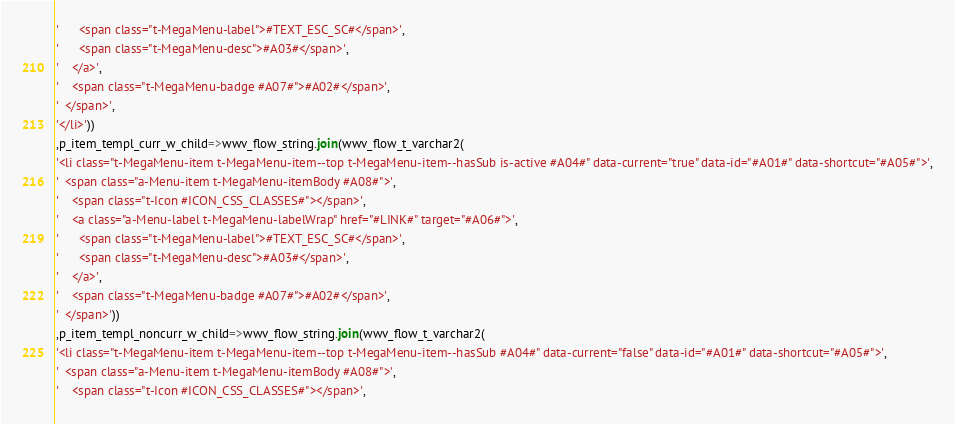<code> <loc_0><loc_0><loc_500><loc_500><_SQL_>'      <span class="t-MegaMenu-label">#TEXT_ESC_SC#</span>',
'      <span class="t-MegaMenu-desc">#A03#</span>',
'    </a>',
'    <span class="t-MegaMenu-badge #A07#">#A02#</span>',
'  </span>',
'</li>'))
,p_item_templ_curr_w_child=>wwv_flow_string.join(wwv_flow_t_varchar2(
'<li class="t-MegaMenu-item t-MegaMenu-item--top t-MegaMenu-item--hasSub is-active #A04#" data-current="true" data-id="#A01#" data-shortcut="#A05#">',
'  <span class="a-Menu-item t-MegaMenu-itemBody #A08#">',
'    <span class="t-Icon #ICON_CSS_CLASSES#"></span>',
'    <a class="a-Menu-label t-MegaMenu-labelWrap" href="#LINK#" target="#A06#">',
'      <span class="t-MegaMenu-label">#TEXT_ESC_SC#</span>',
'      <span class="t-MegaMenu-desc">#A03#</span>',
'    </a>',
'    <span class="t-MegaMenu-badge #A07#">#A02#</span>',
'  </span>'))
,p_item_templ_noncurr_w_child=>wwv_flow_string.join(wwv_flow_t_varchar2(
'<li class="t-MegaMenu-item t-MegaMenu-item--top t-MegaMenu-item--hasSub #A04#" data-current="false" data-id="#A01#" data-shortcut="#A05#">',
'  <span class="a-Menu-item t-MegaMenu-itemBody #A08#">',
'    <span class="t-Icon #ICON_CSS_CLASSES#"></span>',</code> 